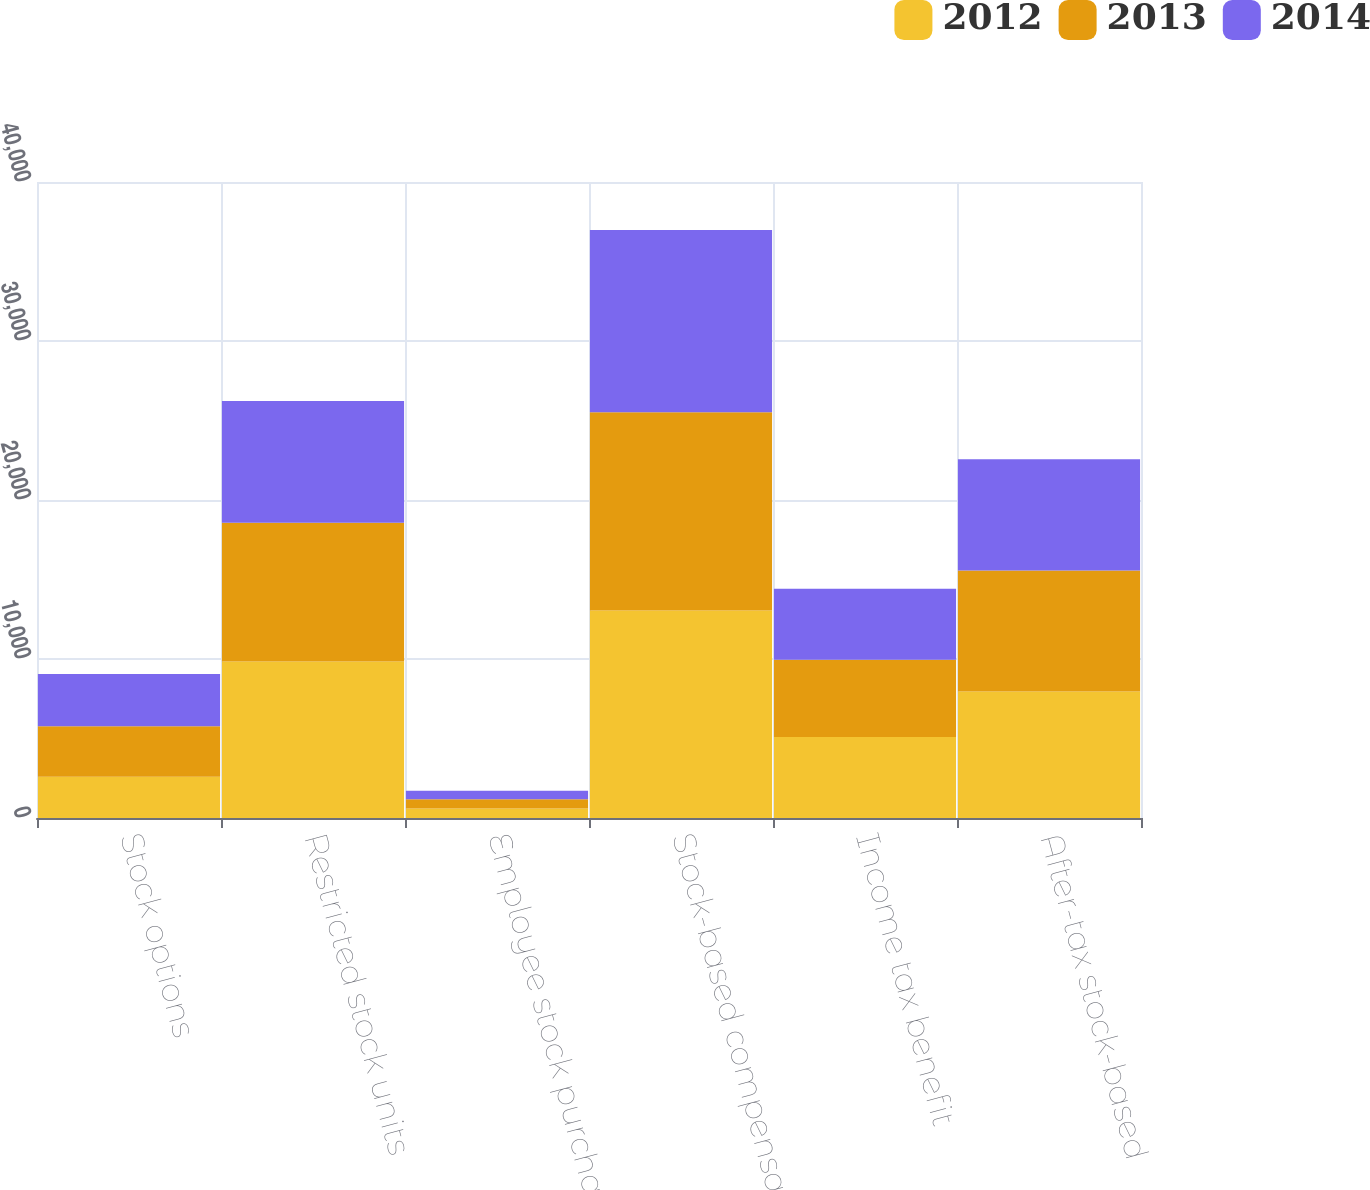Convert chart to OTSL. <chart><loc_0><loc_0><loc_500><loc_500><stacked_bar_chart><ecel><fcel>Stock options<fcel>Restricted stock units<fcel>Employee stock purchase plan<fcel>Stock-based compensation in<fcel>Income tax benefit<fcel>After-tax stock-based<nl><fcel>2012<fcel>2602<fcel>9848<fcel>593<fcel>13043<fcel>5087<fcel>7956<nl><fcel>2013<fcel>3170<fcel>8718<fcel>586<fcel>12474<fcel>4865<fcel>7609<nl><fcel>2014<fcel>3282<fcel>7658<fcel>530<fcel>11470<fcel>4473<fcel>6997<nl></chart> 